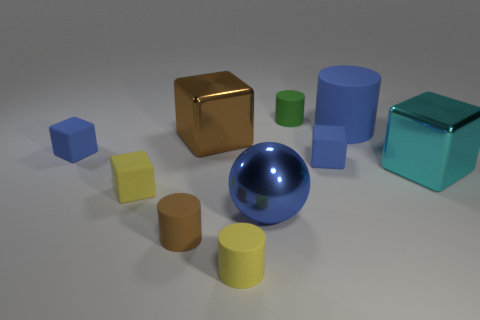How many blue blocks must be subtracted to get 1 blue blocks? 1 Subtract all gray balls. How many blue blocks are left? 2 Subtract all large blue matte cylinders. How many cylinders are left? 3 Subtract all brown cylinders. How many cylinders are left? 3 Subtract 1 cylinders. How many cylinders are left? 3 Subtract all cyan blocks. Subtract all cyan cylinders. How many blocks are left? 4 Subtract 1 cyan blocks. How many objects are left? 9 Subtract all spheres. How many objects are left? 9 Subtract all big cylinders. Subtract all cyan metal blocks. How many objects are left? 8 Add 9 cyan objects. How many cyan objects are left? 10 